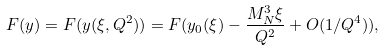<formula> <loc_0><loc_0><loc_500><loc_500>F ( y ) = F ( y ( \xi , Q ^ { 2 } ) ) = F ( y _ { 0 } ( \xi ) - \frac { M ^ { 3 } _ { N } \xi } { Q ^ { 2 } } + O ( 1 / Q ^ { 4 } ) ) ,</formula> 